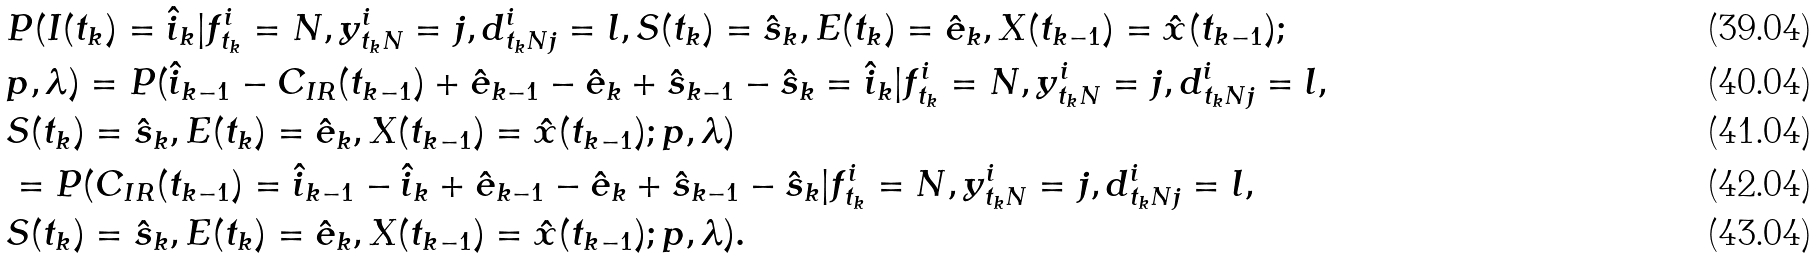Convert formula to latex. <formula><loc_0><loc_0><loc_500><loc_500>& P ( I ( t _ { k } ) = \hat { i } _ { k } | f ^ { i } _ { t _ { k } } = N , y ^ { i } _ { t _ { k } N } = j , d ^ { i } _ { t _ { k } N j } = l , S ( t _ { k } ) = \hat { s } _ { k } , E ( t _ { k } ) = \hat { e } _ { k } , X ( t _ { k - 1 } ) = \hat { x } ( t _ { k - 1 } ) ; \\ & p , \lambda ) = P ( \hat { i } _ { k - 1 } - C _ { I R } ( t _ { k - 1 } ) + \hat { e } _ { k - 1 } - \hat { e } _ { k } + \hat { s } _ { k - 1 } - \hat { s } _ { k } = \hat { i } _ { k } | f ^ { i } _ { t _ { k } } = N , y ^ { i } _ { t _ { k } N } = j , d ^ { i } _ { t _ { k } N j } = l , \\ & S ( t _ { k } ) = \hat { s } _ { k } , E ( t _ { k } ) = \hat { e } _ { k } , X ( t _ { k - 1 } ) = \hat { x } ( t _ { k - 1 } ) ; p , \lambda ) \\ & = P ( C _ { I R } ( t _ { k - 1 } ) = \hat { i } _ { k - 1 } - \hat { i } _ { k } + \hat { e } _ { k - 1 } - \hat { e } _ { k } + \hat { s } _ { k - 1 } - \hat { s } _ { k } | f ^ { i } _ { t _ { k } } = N , y ^ { i } _ { t _ { k } N } = j , d ^ { i } _ { t _ { k } N j } = l , \\ & S ( t _ { k } ) = \hat { s } _ { k } , E ( t _ { k } ) = \hat { e } _ { k } , X ( t _ { k - 1 } ) = \hat { x } ( t _ { k - 1 } ) ; p , \lambda ) .</formula> 